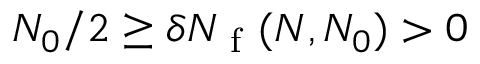<formula> <loc_0><loc_0><loc_500><loc_500>N _ { 0 } / 2 \geq \delta N _ { f } ( N , N _ { 0 } ) > 0</formula> 